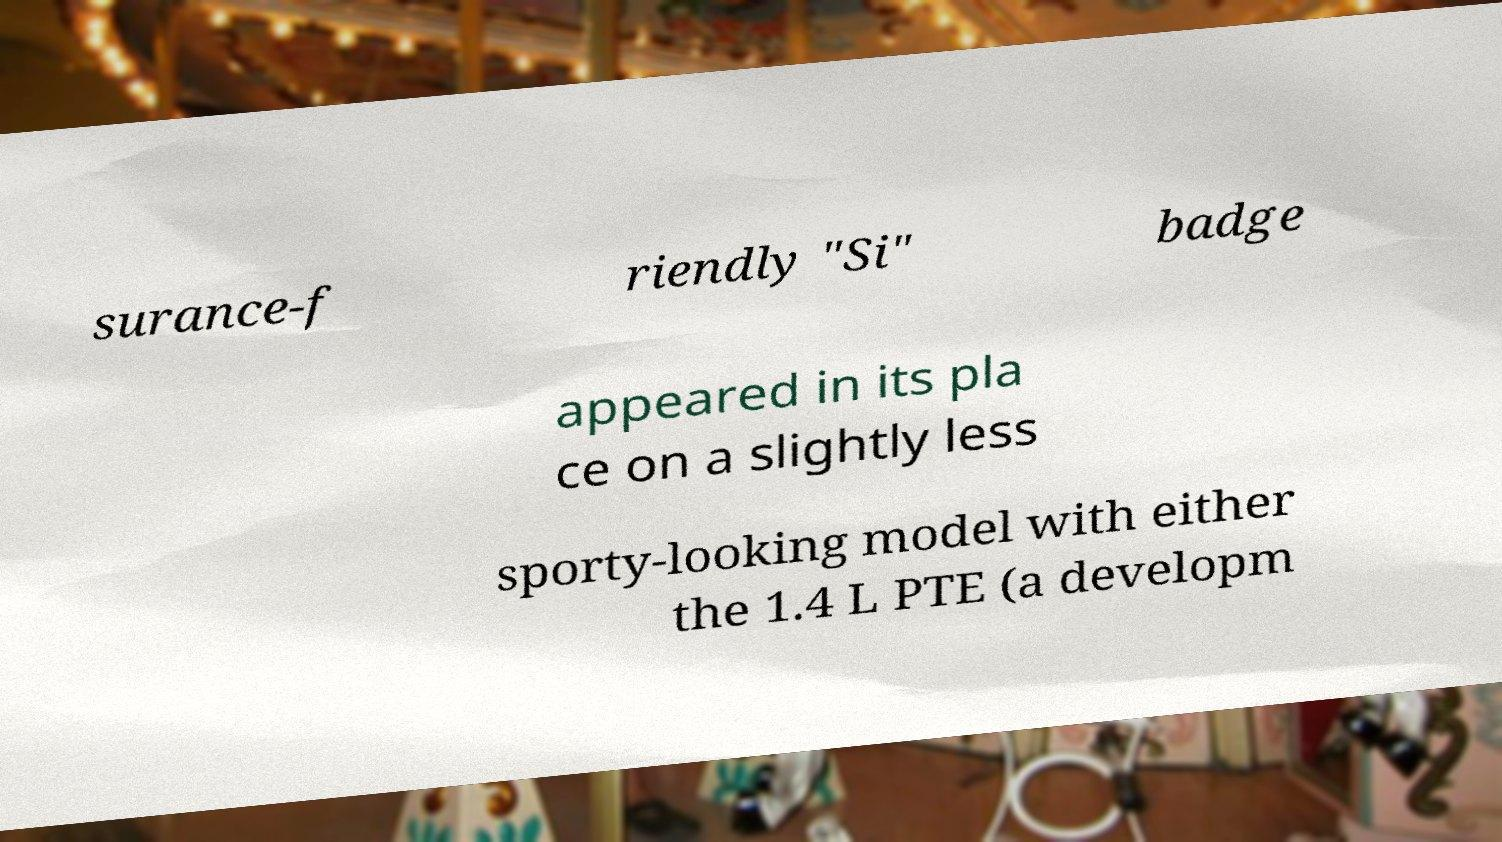What messages or text are displayed in this image? I need them in a readable, typed format. surance-f riendly "Si" badge appeared in its pla ce on a slightly less sporty-looking model with either the 1.4 L PTE (a developm 